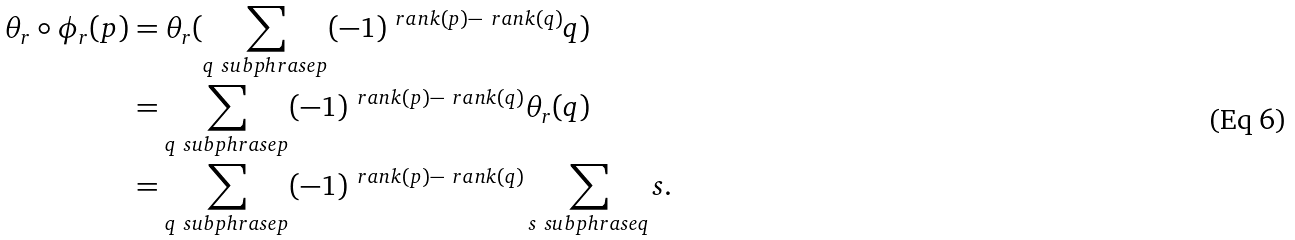Convert formula to latex. <formula><loc_0><loc_0><loc_500><loc_500>\theta _ { r } \circ \phi _ { r } ( p ) & = \theta _ { r } ( \sum _ { q \ s u b p h r a s e p } ( - 1 ) ^ { \ r a n k ( p ) - \ r a n k ( q ) } q ) \\ & = \sum _ { q \ s u b p h r a s e p } ( - 1 ) ^ { \ r a n k ( p ) - \ r a n k ( q ) } \theta _ { r } ( q ) \\ & = \sum _ { q \ s u b p h r a s e p } ( - 1 ) ^ { \ r a n k ( p ) - \ r a n k ( q ) } \sum _ { s \ s u b p h r a s e q } s .</formula> 